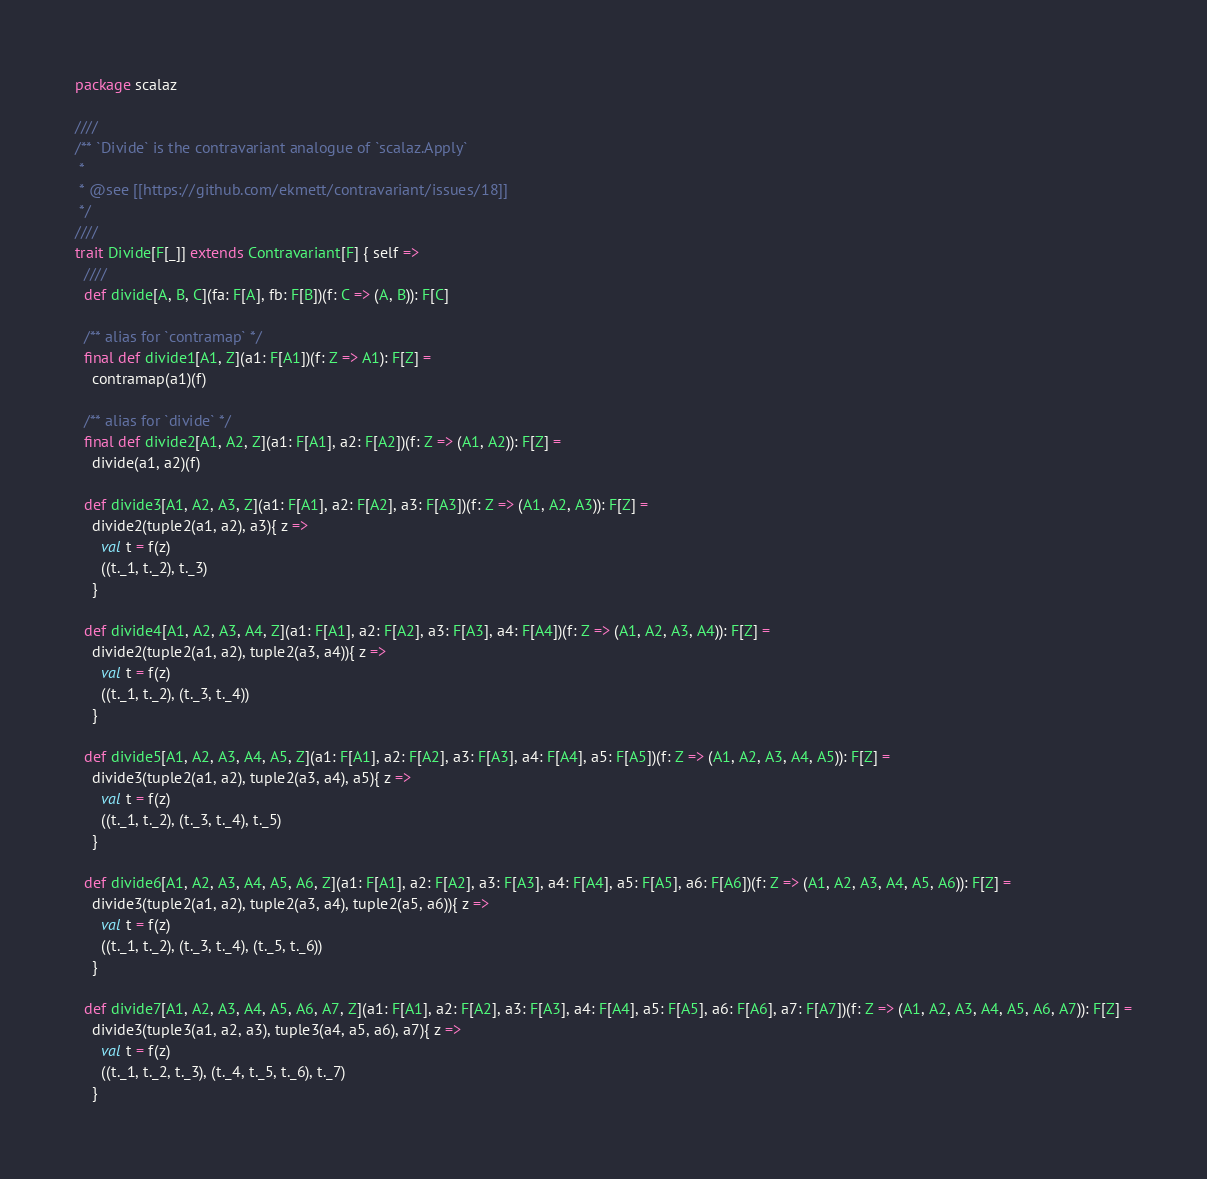Convert code to text. <code><loc_0><loc_0><loc_500><loc_500><_Scala_>package scalaz

////
/** `Divide` is the contravariant analogue of `scalaz.Apply`
 *
 * @see [[https://github.com/ekmett/contravariant/issues/18]]
 */
////
trait Divide[F[_]] extends Contravariant[F] { self =>
  ////
  def divide[A, B, C](fa: F[A], fb: F[B])(f: C => (A, B)): F[C]

  /** alias for `contramap` */
  final def divide1[A1, Z](a1: F[A1])(f: Z => A1): F[Z] =
    contramap(a1)(f)

  /** alias for `divide` */
  final def divide2[A1, A2, Z](a1: F[A1], a2: F[A2])(f: Z => (A1, A2)): F[Z] =
    divide(a1, a2)(f)

  def divide3[A1, A2, A3, Z](a1: F[A1], a2: F[A2], a3: F[A3])(f: Z => (A1, A2, A3)): F[Z] =
    divide2(tuple2(a1, a2), a3){ z =>
      val t = f(z)
      ((t._1, t._2), t._3)
    }

  def divide4[A1, A2, A3, A4, Z](a1: F[A1], a2: F[A2], a3: F[A3], a4: F[A4])(f: Z => (A1, A2, A3, A4)): F[Z] =
    divide2(tuple2(a1, a2), tuple2(a3, a4)){ z =>
      val t = f(z)
      ((t._1, t._2), (t._3, t._4))
    }

  def divide5[A1, A2, A3, A4, A5, Z](a1: F[A1], a2: F[A2], a3: F[A3], a4: F[A4], a5: F[A5])(f: Z => (A1, A2, A3, A4, A5)): F[Z] =
    divide3(tuple2(a1, a2), tuple2(a3, a4), a5){ z =>
      val t = f(z)
      ((t._1, t._2), (t._3, t._4), t._5)
    }

  def divide6[A1, A2, A3, A4, A5, A6, Z](a1: F[A1], a2: F[A2], a3: F[A3], a4: F[A4], a5: F[A5], a6: F[A6])(f: Z => (A1, A2, A3, A4, A5, A6)): F[Z] =
    divide3(tuple2(a1, a2), tuple2(a3, a4), tuple2(a5, a6)){ z =>
      val t = f(z)
      ((t._1, t._2), (t._3, t._4), (t._5, t._6))
    }

  def divide7[A1, A2, A3, A4, A5, A6, A7, Z](a1: F[A1], a2: F[A2], a3: F[A3], a4: F[A4], a5: F[A5], a6: F[A6], a7: F[A7])(f: Z => (A1, A2, A3, A4, A5, A6, A7)): F[Z] =
    divide3(tuple3(a1, a2, a3), tuple3(a4, a5, a6), a7){ z =>
      val t = f(z)
      ((t._1, t._2, t._3), (t._4, t._5, t._6), t._7)
    }
</code> 